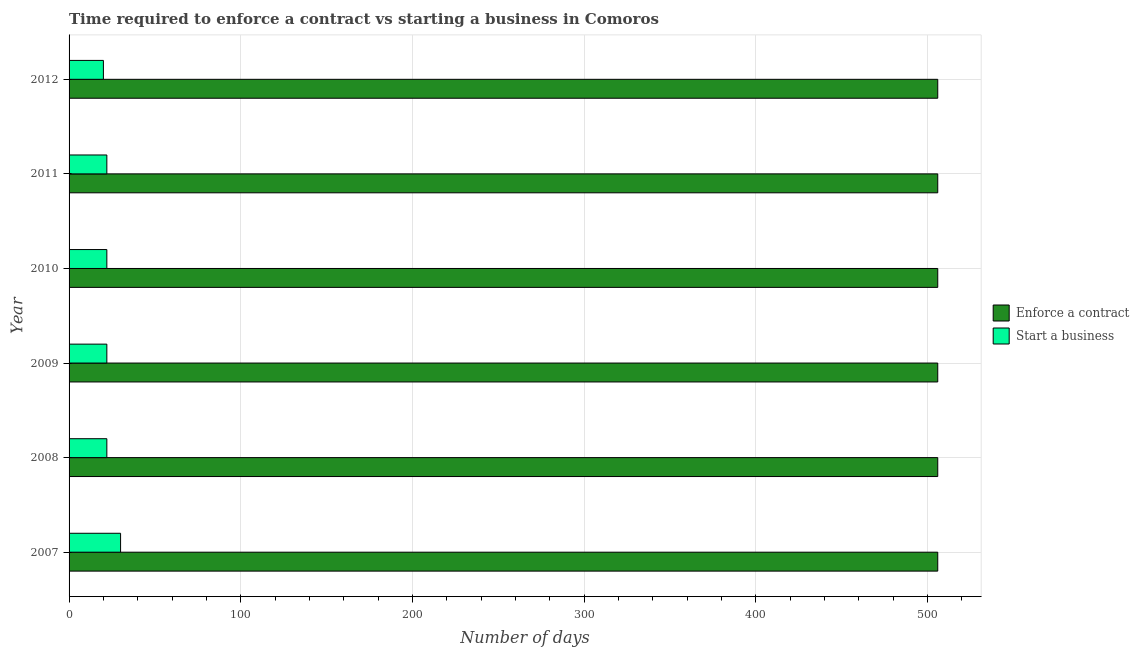Are the number of bars per tick equal to the number of legend labels?
Keep it short and to the point. Yes. Are the number of bars on each tick of the Y-axis equal?
Give a very brief answer. Yes. In how many cases, is the number of bars for a given year not equal to the number of legend labels?
Make the answer very short. 0. What is the number of days to start a business in 2008?
Your answer should be compact. 22. Across all years, what is the maximum number of days to enforece a contract?
Offer a very short reply. 506. Across all years, what is the minimum number of days to enforece a contract?
Keep it short and to the point. 506. In which year was the number of days to enforece a contract minimum?
Your answer should be compact. 2007. What is the total number of days to start a business in the graph?
Keep it short and to the point. 138. What is the difference between the number of days to enforece a contract in 2010 and the number of days to start a business in 2007?
Offer a very short reply. 476. In the year 2008, what is the difference between the number of days to start a business and number of days to enforece a contract?
Give a very brief answer. -484. In how many years, is the number of days to enforece a contract greater than 40 days?
Your answer should be compact. 6. What is the ratio of the number of days to start a business in 2007 to that in 2009?
Make the answer very short. 1.36. Is the number of days to start a business in 2010 less than that in 2011?
Your answer should be compact. No. What is the difference between the highest and the second highest number of days to enforece a contract?
Give a very brief answer. 0. In how many years, is the number of days to start a business greater than the average number of days to start a business taken over all years?
Ensure brevity in your answer.  1. What does the 2nd bar from the top in 2010 represents?
Your response must be concise. Enforce a contract. What does the 1st bar from the bottom in 2007 represents?
Ensure brevity in your answer.  Enforce a contract. What is the difference between two consecutive major ticks on the X-axis?
Offer a very short reply. 100. What is the title of the graph?
Keep it short and to the point. Time required to enforce a contract vs starting a business in Comoros. Does "GDP per capita" appear as one of the legend labels in the graph?
Offer a terse response. No. What is the label or title of the X-axis?
Make the answer very short. Number of days. What is the Number of days in Enforce a contract in 2007?
Keep it short and to the point. 506. What is the Number of days in Start a business in 2007?
Keep it short and to the point. 30. What is the Number of days in Enforce a contract in 2008?
Provide a short and direct response. 506. What is the Number of days in Enforce a contract in 2009?
Your answer should be compact. 506. What is the Number of days of Enforce a contract in 2010?
Provide a succinct answer. 506. What is the Number of days of Enforce a contract in 2011?
Give a very brief answer. 506. What is the Number of days in Enforce a contract in 2012?
Keep it short and to the point. 506. What is the Number of days in Start a business in 2012?
Your answer should be compact. 20. Across all years, what is the maximum Number of days of Enforce a contract?
Provide a succinct answer. 506. Across all years, what is the minimum Number of days of Enforce a contract?
Give a very brief answer. 506. Across all years, what is the minimum Number of days in Start a business?
Provide a short and direct response. 20. What is the total Number of days in Enforce a contract in the graph?
Provide a succinct answer. 3036. What is the total Number of days in Start a business in the graph?
Your answer should be compact. 138. What is the difference between the Number of days in Enforce a contract in 2007 and that in 2009?
Your response must be concise. 0. What is the difference between the Number of days in Start a business in 2007 and that in 2010?
Your response must be concise. 8. What is the difference between the Number of days in Start a business in 2007 and that in 2011?
Ensure brevity in your answer.  8. What is the difference between the Number of days of Enforce a contract in 2008 and that in 2009?
Make the answer very short. 0. What is the difference between the Number of days of Start a business in 2008 and that in 2009?
Provide a succinct answer. 0. What is the difference between the Number of days in Enforce a contract in 2008 and that in 2010?
Your answer should be very brief. 0. What is the difference between the Number of days in Start a business in 2008 and that in 2010?
Provide a succinct answer. 0. What is the difference between the Number of days in Enforce a contract in 2008 and that in 2011?
Your response must be concise. 0. What is the difference between the Number of days in Start a business in 2008 and that in 2012?
Provide a succinct answer. 2. What is the difference between the Number of days of Start a business in 2009 and that in 2010?
Make the answer very short. 0. What is the difference between the Number of days of Enforce a contract in 2009 and that in 2011?
Offer a terse response. 0. What is the difference between the Number of days in Enforce a contract in 2009 and that in 2012?
Provide a short and direct response. 0. What is the difference between the Number of days in Start a business in 2009 and that in 2012?
Keep it short and to the point. 2. What is the difference between the Number of days in Enforce a contract in 2010 and that in 2011?
Keep it short and to the point. 0. What is the difference between the Number of days of Start a business in 2010 and that in 2012?
Offer a terse response. 2. What is the difference between the Number of days in Enforce a contract in 2011 and that in 2012?
Give a very brief answer. 0. What is the difference between the Number of days in Enforce a contract in 2007 and the Number of days in Start a business in 2008?
Make the answer very short. 484. What is the difference between the Number of days of Enforce a contract in 2007 and the Number of days of Start a business in 2009?
Offer a terse response. 484. What is the difference between the Number of days in Enforce a contract in 2007 and the Number of days in Start a business in 2010?
Ensure brevity in your answer.  484. What is the difference between the Number of days of Enforce a contract in 2007 and the Number of days of Start a business in 2011?
Make the answer very short. 484. What is the difference between the Number of days in Enforce a contract in 2007 and the Number of days in Start a business in 2012?
Provide a succinct answer. 486. What is the difference between the Number of days in Enforce a contract in 2008 and the Number of days in Start a business in 2009?
Your answer should be compact. 484. What is the difference between the Number of days in Enforce a contract in 2008 and the Number of days in Start a business in 2010?
Provide a succinct answer. 484. What is the difference between the Number of days in Enforce a contract in 2008 and the Number of days in Start a business in 2011?
Make the answer very short. 484. What is the difference between the Number of days in Enforce a contract in 2008 and the Number of days in Start a business in 2012?
Offer a very short reply. 486. What is the difference between the Number of days in Enforce a contract in 2009 and the Number of days in Start a business in 2010?
Provide a succinct answer. 484. What is the difference between the Number of days of Enforce a contract in 2009 and the Number of days of Start a business in 2011?
Ensure brevity in your answer.  484. What is the difference between the Number of days in Enforce a contract in 2009 and the Number of days in Start a business in 2012?
Provide a succinct answer. 486. What is the difference between the Number of days of Enforce a contract in 2010 and the Number of days of Start a business in 2011?
Your answer should be compact. 484. What is the difference between the Number of days in Enforce a contract in 2010 and the Number of days in Start a business in 2012?
Your answer should be very brief. 486. What is the difference between the Number of days of Enforce a contract in 2011 and the Number of days of Start a business in 2012?
Your response must be concise. 486. What is the average Number of days of Enforce a contract per year?
Your answer should be very brief. 506. In the year 2007, what is the difference between the Number of days in Enforce a contract and Number of days in Start a business?
Your answer should be very brief. 476. In the year 2008, what is the difference between the Number of days in Enforce a contract and Number of days in Start a business?
Keep it short and to the point. 484. In the year 2009, what is the difference between the Number of days in Enforce a contract and Number of days in Start a business?
Your response must be concise. 484. In the year 2010, what is the difference between the Number of days in Enforce a contract and Number of days in Start a business?
Offer a very short reply. 484. In the year 2011, what is the difference between the Number of days of Enforce a contract and Number of days of Start a business?
Offer a very short reply. 484. In the year 2012, what is the difference between the Number of days in Enforce a contract and Number of days in Start a business?
Your response must be concise. 486. What is the ratio of the Number of days in Enforce a contract in 2007 to that in 2008?
Keep it short and to the point. 1. What is the ratio of the Number of days in Start a business in 2007 to that in 2008?
Your response must be concise. 1.36. What is the ratio of the Number of days in Enforce a contract in 2007 to that in 2009?
Provide a succinct answer. 1. What is the ratio of the Number of days in Start a business in 2007 to that in 2009?
Offer a terse response. 1.36. What is the ratio of the Number of days in Start a business in 2007 to that in 2010?
Offer a terse response. 1.36. What is the ratio of the Number of days in Enforce a contract in 2007 to that in 2011?
Your response must be concise. 1. What is the ratio of the Number of days in Start a business in 2007 to that in 2011?
Offer a terse response. 1.36. What is the ratio of the Number of days in Enforce a contract in 2008 to that in 2009?
Your answer should be very brief. 1. What is the ratio of the Number of days in Start a business in 2008 to that in 2009?
Give a very brief answer. 1. What is the ratio of the Number of days in Enforce a contract in 2008 to that in 2010?
Make the answer very short. 1. What is the ratio of the Number of days in Enforce a contract in 2008 to that in 2011?
Give a very brief answer. 1. What is the ratio of the Number of days in Enforce a contract in 2008 to that in 2012?
Your answer should be very brief. 1. What is the ratio of the Number of days of Start a business in 2008 to that in 2012?
Offer a very short reply. 1.1. What is the ratio of the Number of days in Enforce a contract in 2009 to that in 2011?
Give a very brief answer. 1. What is the ratio of the Number of days in Start a business in 2009 to that in 2011?
Provide a short and direct response. 1. What is the ratio of the Number of days of Enforce a contract in 2009 to that in 2012?
Your response must be concise. 1. What is the ratio of the Number of days in Start a business in 2010 to that in 2011?
Make the answer very short. 1. What is the ratio of the Number of days of Enforce a contract in 2010 to that in 2012?
Provide a succinct answer. 1. What is the ratio of the Number of days of Start a business in 2010 to that in 2012?
Keep it short and to the point. 1.1. What is the ratio of the Number of days in Enforce a contract in 2011 to that in 2012?
Your answer should be very brief. 1. What is the difference between the highest and the lowest Number of days of Start a business?
Make the answer very short. 10. 